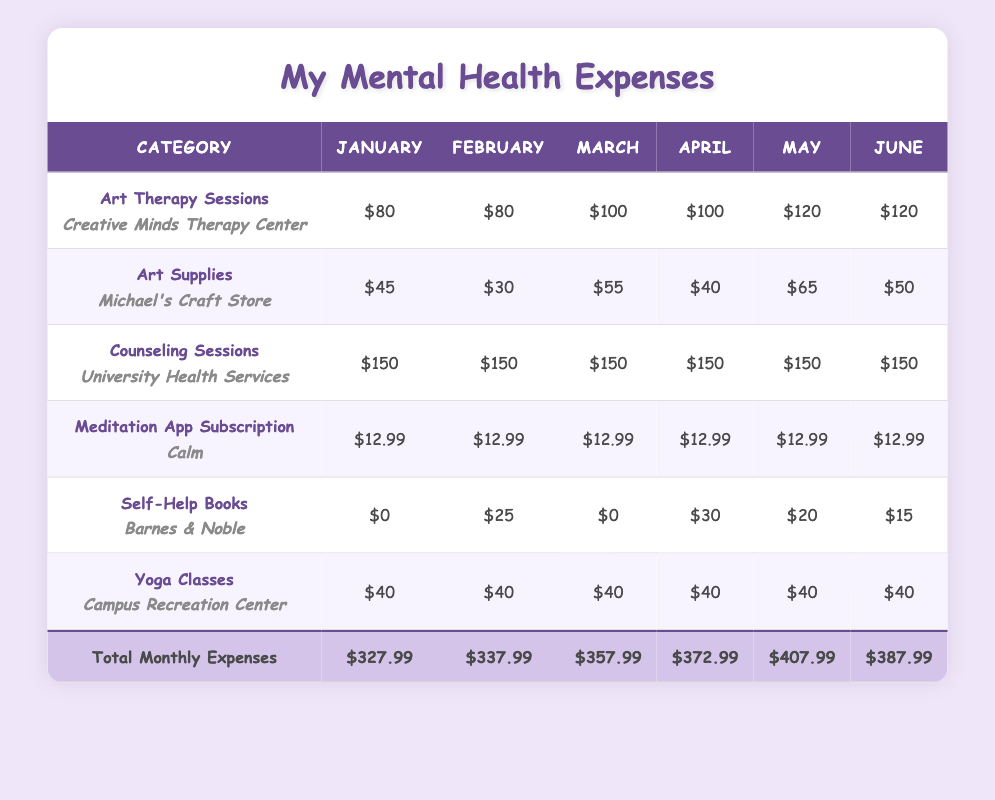What were the art therapy session costs in April? The table shows that in April, the cost for art therapy sessions was $100.
Answer: $100 Which month had the highest total monthly expenses? To find the highest total monthly expenses, we compare the total costs from each month: January ($327.99), February ($337.99), March ($357.99), April ($372.99), May ($407.99), and June ($387.99). May has the highest total at $407.99.
Answer: $407.99 How much did I spend on self-help books in January? According to the table, the expense for self-help books in January was $0.
Answer: $0 If I combine the costs of art therapy sessions and art supplies for March, what would that total? For March, the cost of art therapy sessions is $100 and the cost of art supplies is $55. Adding these amounts together gives $100 + $55 = $155.
Answer: $155 Did the cost of meditation app subscriptions vary across the months? The table indicates that the cost for meditation app subscriptions remained constant at $12.99 for all months. Therefore, it did not vary.
Answer: No What is the average total monthly expense for the first three months? The total monthly expenses for the first three months are January ($327.99), February ($337.99), and March ($357.99). Adding them gives $327.99 + $337.99 + $357.99 = $1023.97. Dividing by 3 gives an average of $1023.97 / 3 ≈ $341.32.
Answer: $341.32 How much more did I spend on counseling sessions compared to yoga classes in June? In June, counseling sessions cost $150, and yoga classes cost $40. To find the difference, subtract the cost of yoga classes from counseling sessions: $150 - $40 = $110.
Answer: $110 What was the total expense on art supplies from January to June? To calculate the total expense on art supplies, we add the costs from each month: January ($45), February ($30), March ($55), April ($40), May ($65), and June ($50). The total is $45 + $30 + $55 + $40 + $65 + $50 = $285.
Answer: $285 Was there an increase in the cost of art therapy sessions from January to June? The costs of art therapy sessions were $80 in January and increased to $120 in June, indicating an increase.
Answer: Yes 